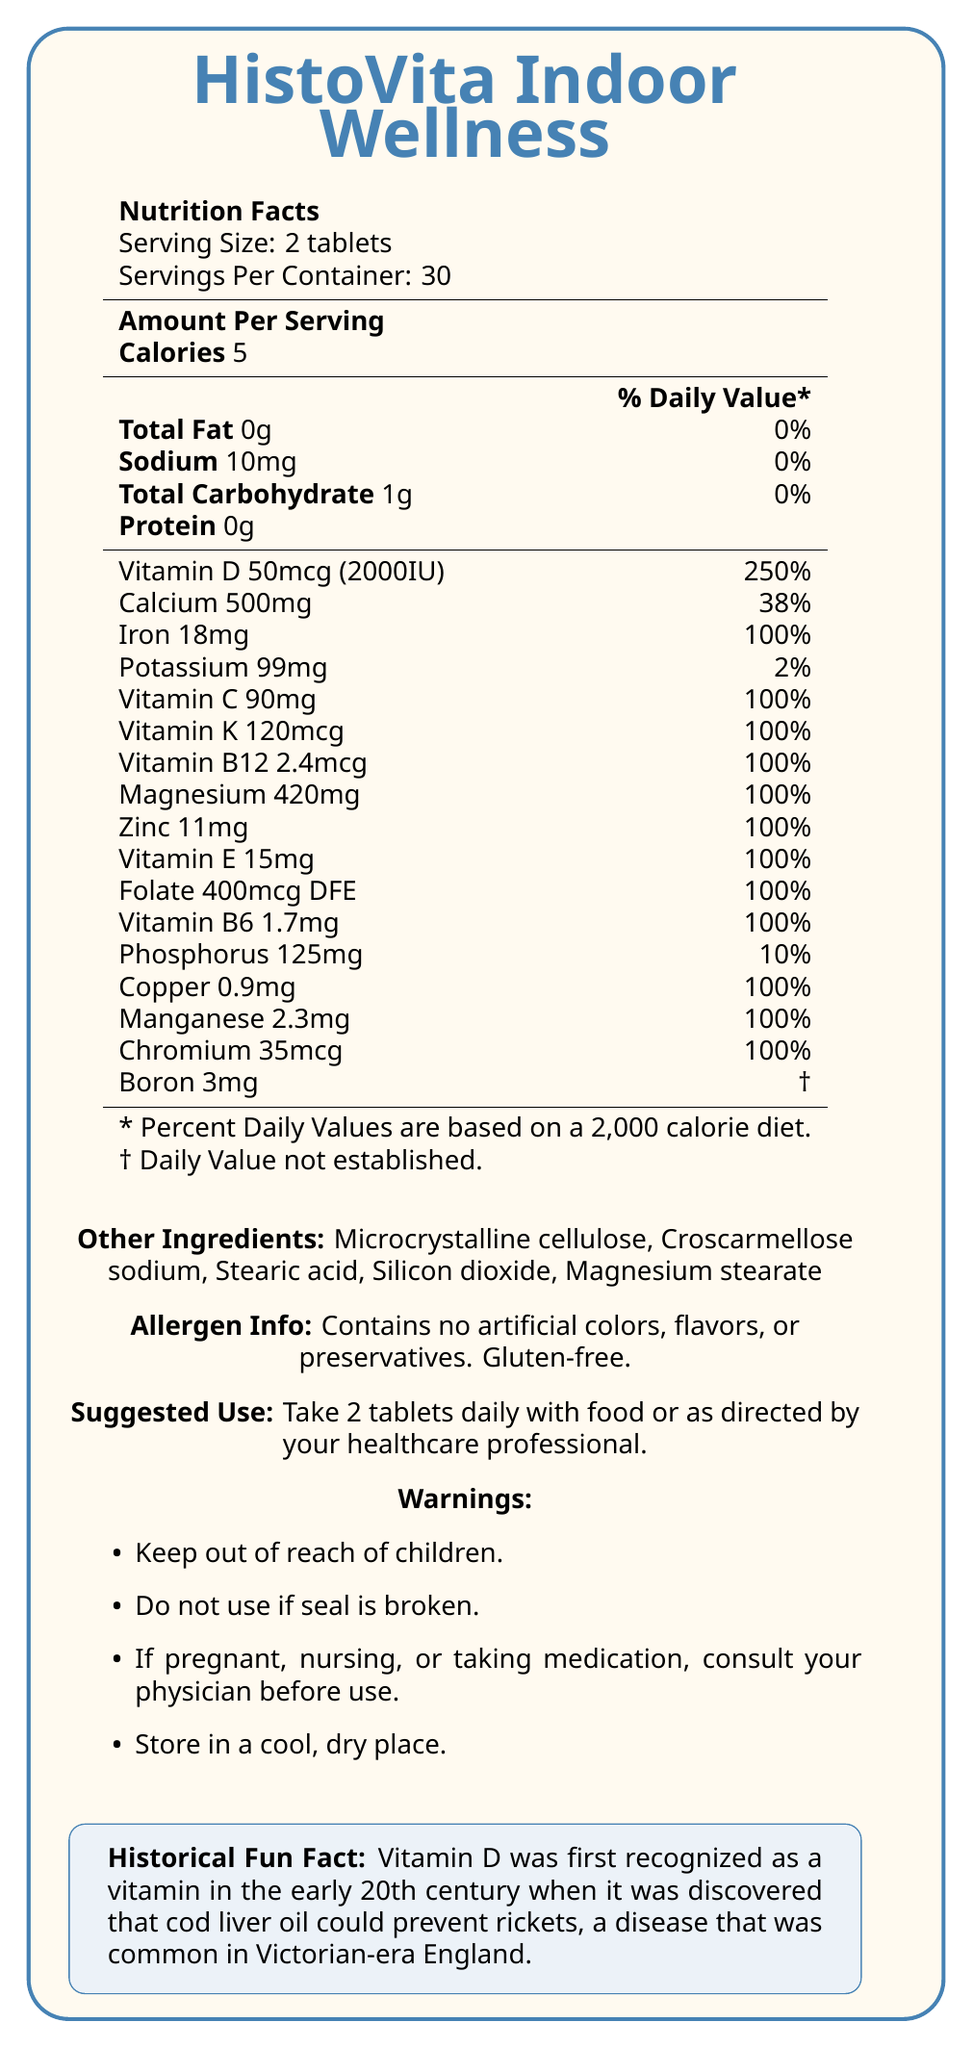what is the serving size? The document lists the serving size as "2 tablets".
Answer: 2 tablets how many servings are in one container? The document mentions "Servings Per Container: 30".
Answer: 30 servings how much vitamin D is in one serving? Under "Amount Per Serving," it states "Vitamin D 50mcg (2000IU)".
Answer: 50mcg (2000IU) what is the percentage of daily value for calcium per serving? The document shows "Calcium 500mg" with a daily value percentage of "38%".
Answer: 38% what should you do if the seal is broken? One of the warnings states: "Do not use if seal is broken."
Answer: Do not use which of the following vitamins has a daily value percentage of 100% per serving? A. Vitamin K B. Vitamin D C. Vitamin C D. Vitamin E The document lists Vitamin C as "90mg" with a daily value percentage of "100%".
Answer: C what is the total amount of calories per serving? The document specifies "Calories 5" under the nutrition facts.
Answer: 5 calories is this supplement gluten-free? The allergen information mentions: "Contains no artificial colors, flavors, or preservatives. Gluten-free."
Answer: Yes what is the historical fun fact mentioned in the document? The document includes a historical fun fact about Vitamin D.
Answer: Vitamin D was first recognized as a vitamin in the early 20th century when it was discovered that cod liver oil could prevent rickets, a disease that was common in Victorian-era England. list two other ingredients found in HistoVita Indoor Wellness. The document lists "Other Ingredients: Microcrystalline cellulose, Croscarmellose sodium, Stearic acid, Silicon dioxide, Magnesium stearate."
Answer: Microcrystalline cellulose, Stearic acid is folate included in this supplement? The document shows "Folate 400mcg DFE" in the nutrition facts table.
Answer: Yes which mineral has a daily value percentage listed as 10%? The nutrition facts table lists "Phosphorus 125mg" with a daily value percentage of "10%".
Answer: Phosphorus describe the main idea of the document. The main sections of the document include the product name, serving size, number of servings, detailed nutrition information, ingredients, allergen information, suggested use instructions, warnings, and a historical fun fact related to Vitamin D.
Answer: The document provides the nutrition facts, ingredients, allergen information, suggested use, warnings, and a historical fun fact for the HistoVita Indoor Wellness vitamin supplement, which is designed to support an indoor lifestyle and bone health. what is the recommended daily intake of zinc per serving? The nutrition facts table lists "Zinc 11mg".
Answer: 11mg which vitamin has a measurement in both micrograms and international units (IU)? A. Vitamin B6 B. Vitamin D C. Vitamin E D. Vitamin K The document lists "Vitamin D 50mcg (2000IU)".
Answer: B how much iron does one serving contain? The document specifies "Iron 18mg" in the nutrition facts table.
Answer: 18mg what color is used for the document's frame and some text? The document style is specified to use the color "indoorblue" for the frame and some text.
Answer: Indoor blue how much sodium is in one serving? The nutrition facts table includes "Sodium 10mg".
Answer: 10mg can information regarding the manufacturing location be found in the document? The provided document does not include any details about the manufacturing location.
Answer: Not enough information why might someone take HistoVita Indoor Wellness? The supplement is designed to support indoor lifestyle and bone health, as indicated by the name and the high levels of Vitamin D, Calcium, and other essential nutrients.
Answer: To support an indoor lifestyle and bone health 